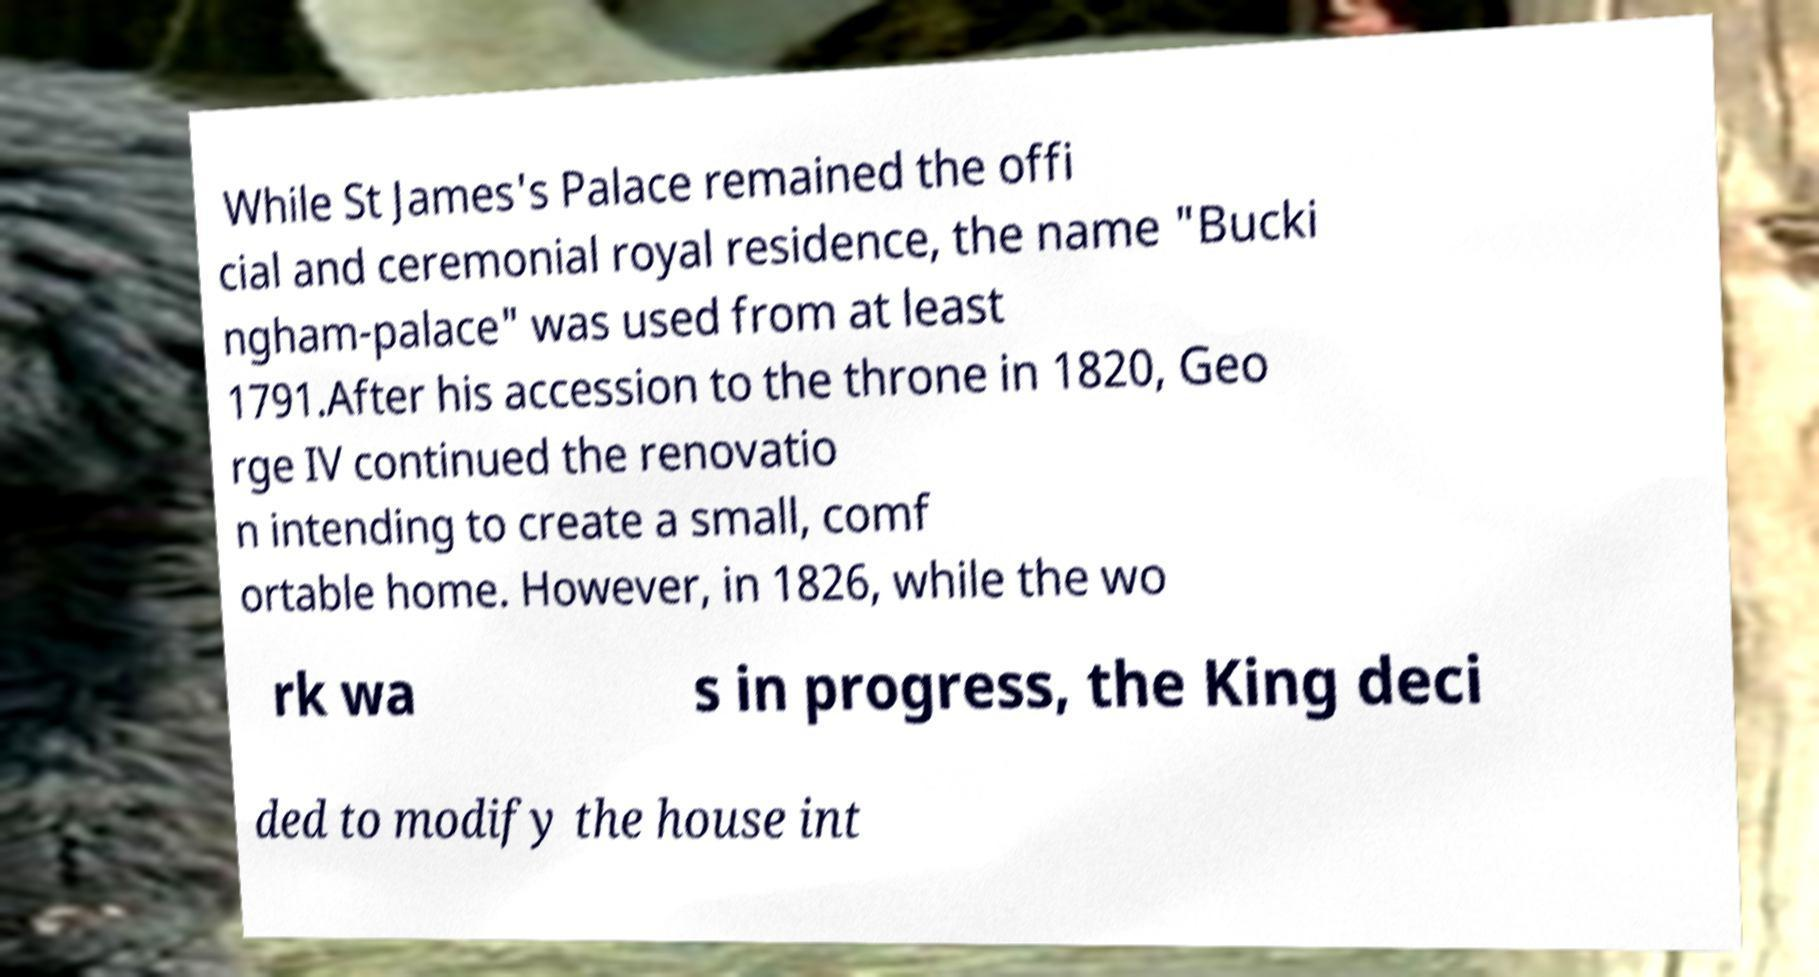I need the written content from this picture converted into text. Can you do that? While St James's Palace remained the offi cial and ceremonial royal residence, the name "Bucki ngham-palace" was used from at least 1791.After his accession to the throne in 1820, Geo rge IV continued the renovatio n intending to create a small, comf ortable home. However, in 1826, while the wo rk wa s in progress, the King deci ded to modify the house int 